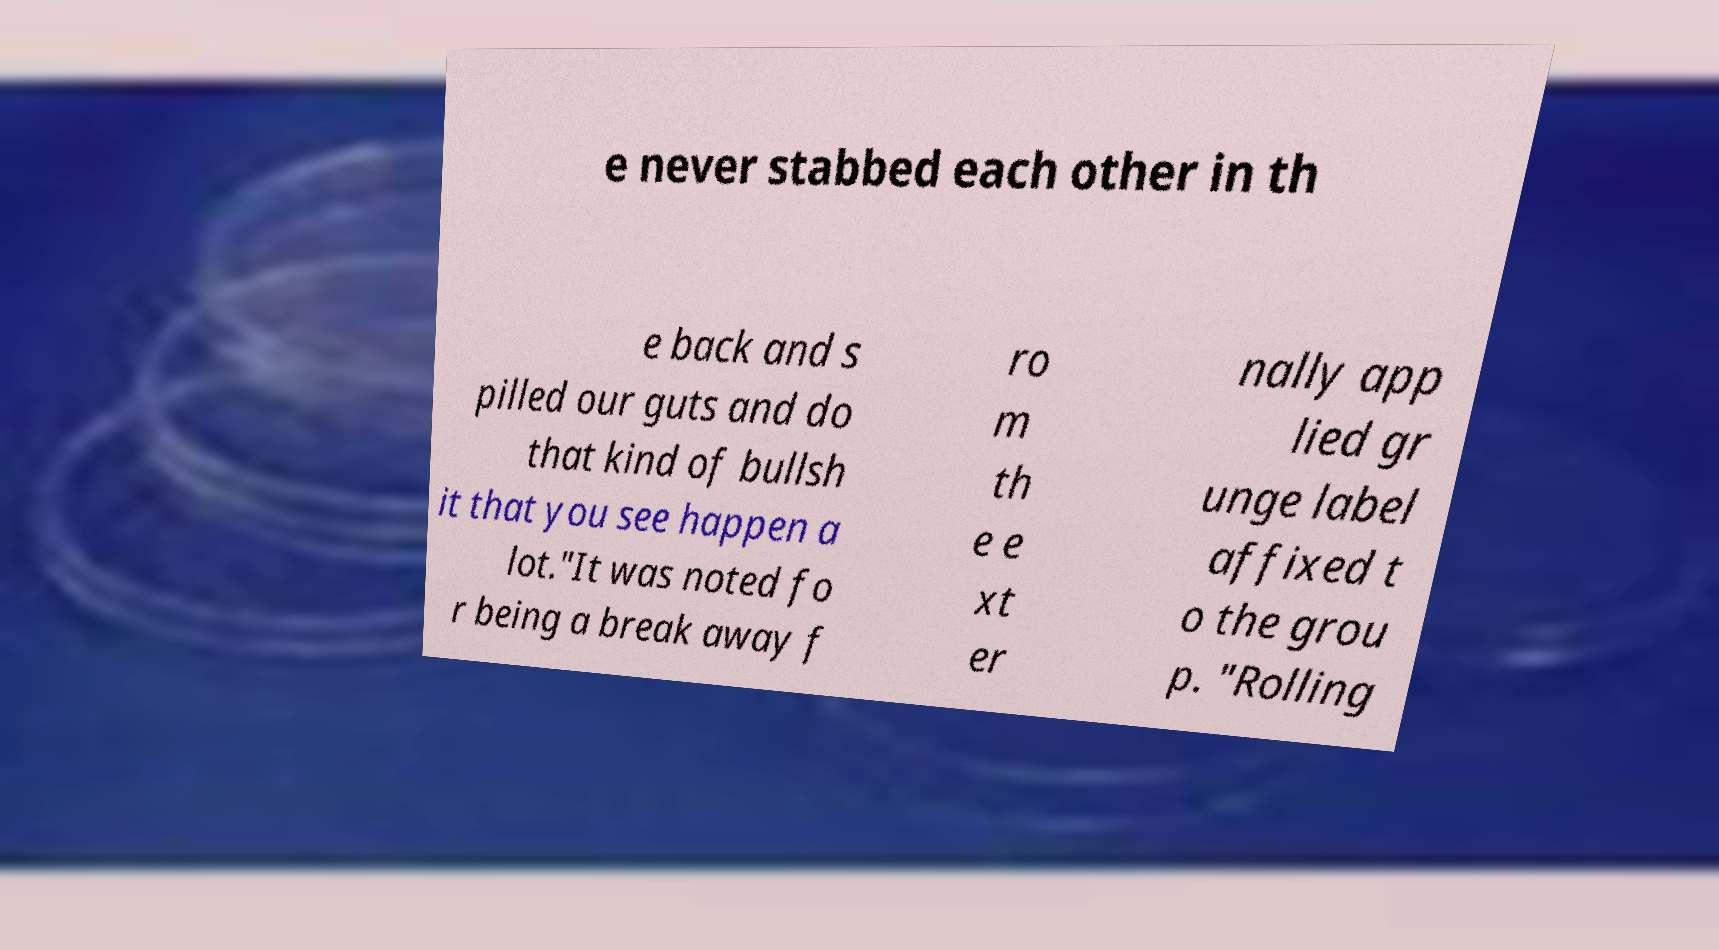Could you assist in decoding the text presented in this image and type it out clearly? e never stabbed each other in th e back and s pilled our guts and do that kind of bullsh it that you see happen a lot."It was noted fo r being a break away f ro m th e e xt er nally app lied gr unge label affixed t o the grou p. "Rolling 